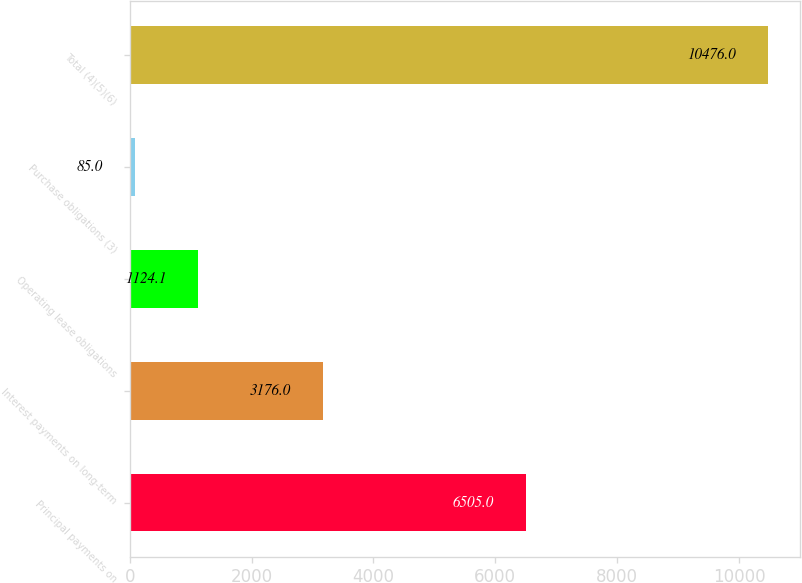Convert chart to OTSL. <chart><loc_0><loc_0><loc_500><loc_500><bar_chart><fcel>Principal payments on<fcel>Interest payments on long-term<fcel>Operating lease obligations<fcel>Purchase obligations (3)<fcel>Total (4)(5)(6)<nl><fcel>6505<fcel>3176<fcel>1124.1<fcel>85<fcel>10476<nl></chart> 